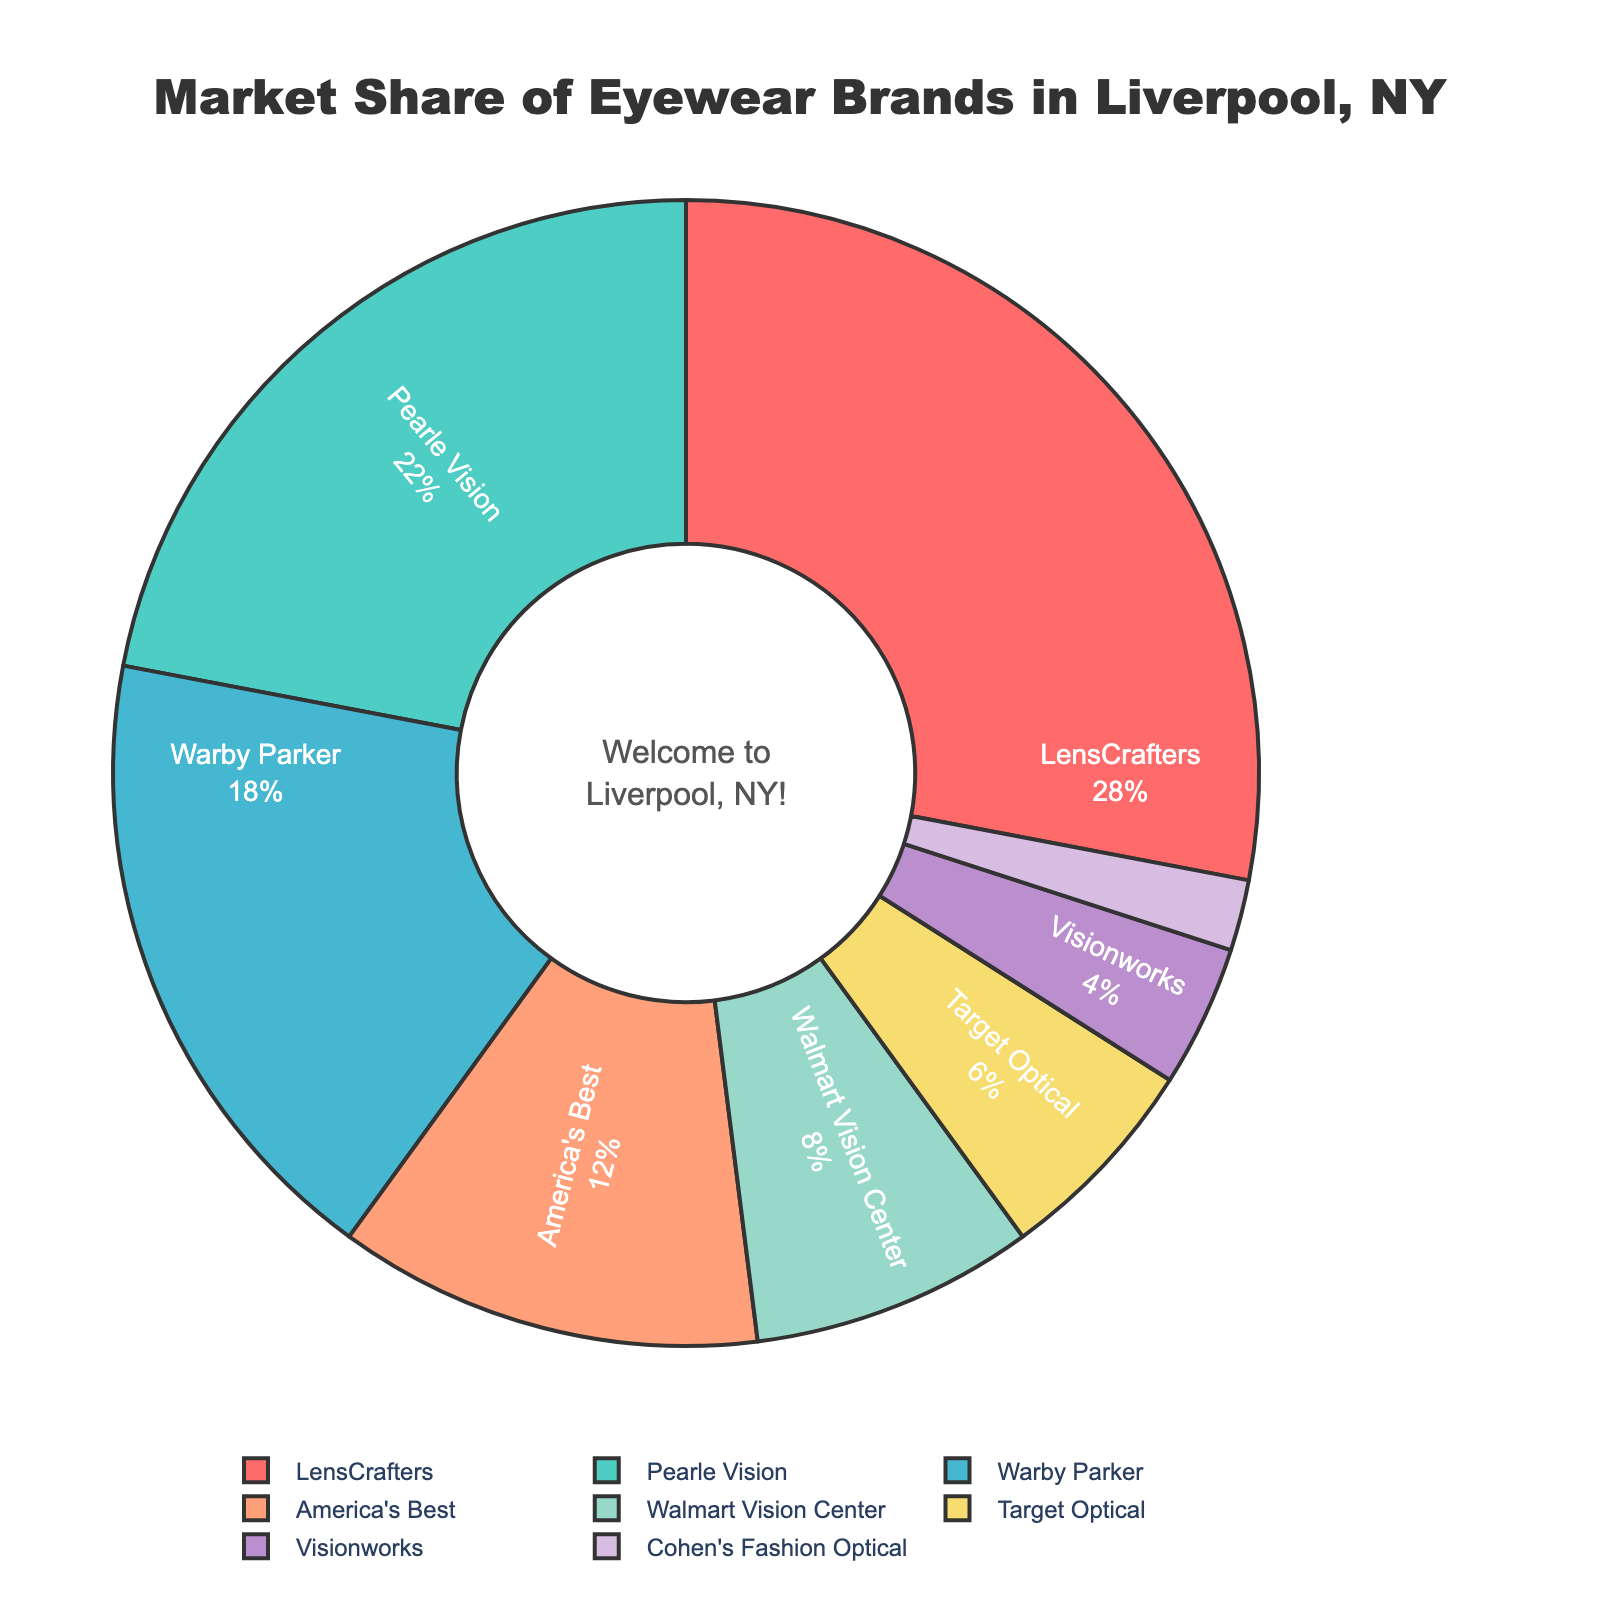What is the market share of the largest eyewear brand in Liverpool, NY? The largest market share in the pie chart corresponds to LensCrafters, which has a market share of 28%.
Answer: 28% Which eye wear brand has the second-largest market share? After identifying the largest market share, the pie chart shows that Pearle Vision has the second-largest market share at 22%.
Answer: Pearle Vision What is the total market share of the top three eyewear brands? Sum the market shares of LensCrafters (28%), Pearle Vision (22%), and Warby Parker (18%) to get the total market share: 28 + 22 + 18 = 68%.
Answer: 68% Is the market share of America's Best greater than that of Walmart Vision Center? From the chart, America's Best has a market share of 12%, while Walmart Vision Center has 8%. Since 12 > 8, America's Best has a greater market share.
Answer: Yes What is the combined market share of the brands with a share less than 5%? Sum the market shares of Visionworks (4%) and Cohen's Fashion Optical (2%): 4 + 2 = 6%.
Answer: 6% Which brands have a market share less than 10%? From the pie chart, the brands with market shares less than 10% are Walmart Vision Center (8%), Target Optical (6%), Visionworks (4%), and Cohen's Fashion Optical (2%).
Answer: Walmart Vision Center, Target Optical, Visionworks, Cohen's Fashion Optical Does Target Optical have a smaller market share compared to America's Best? According to the pie chart, Target Optical has a market share of 6%, whereas America's Best has 12%. Since 6 < 12, Target Optical has a smaller market share.
Answer: Yes What is the difference in market share between Pearle Vision and Warby Parker? Subtract the market share of Warby Parker (18%) from the market share of Pearle Vision (22%): 22 - 18 = 4%.
Answer: 4% What color represents LensCrafters' market share segment on the pie chart? The pie chart uses specific colors to represent each brand. LensCrafters is represented by the color red.
Answer: Red What percentage of the market is captured by brands not in the top three? Sum the market shares of the top three brands: 28 + 22 + 18 = 68%. Subtract this from 100%: 100 - 68 = 32%.
Answer: 32% 